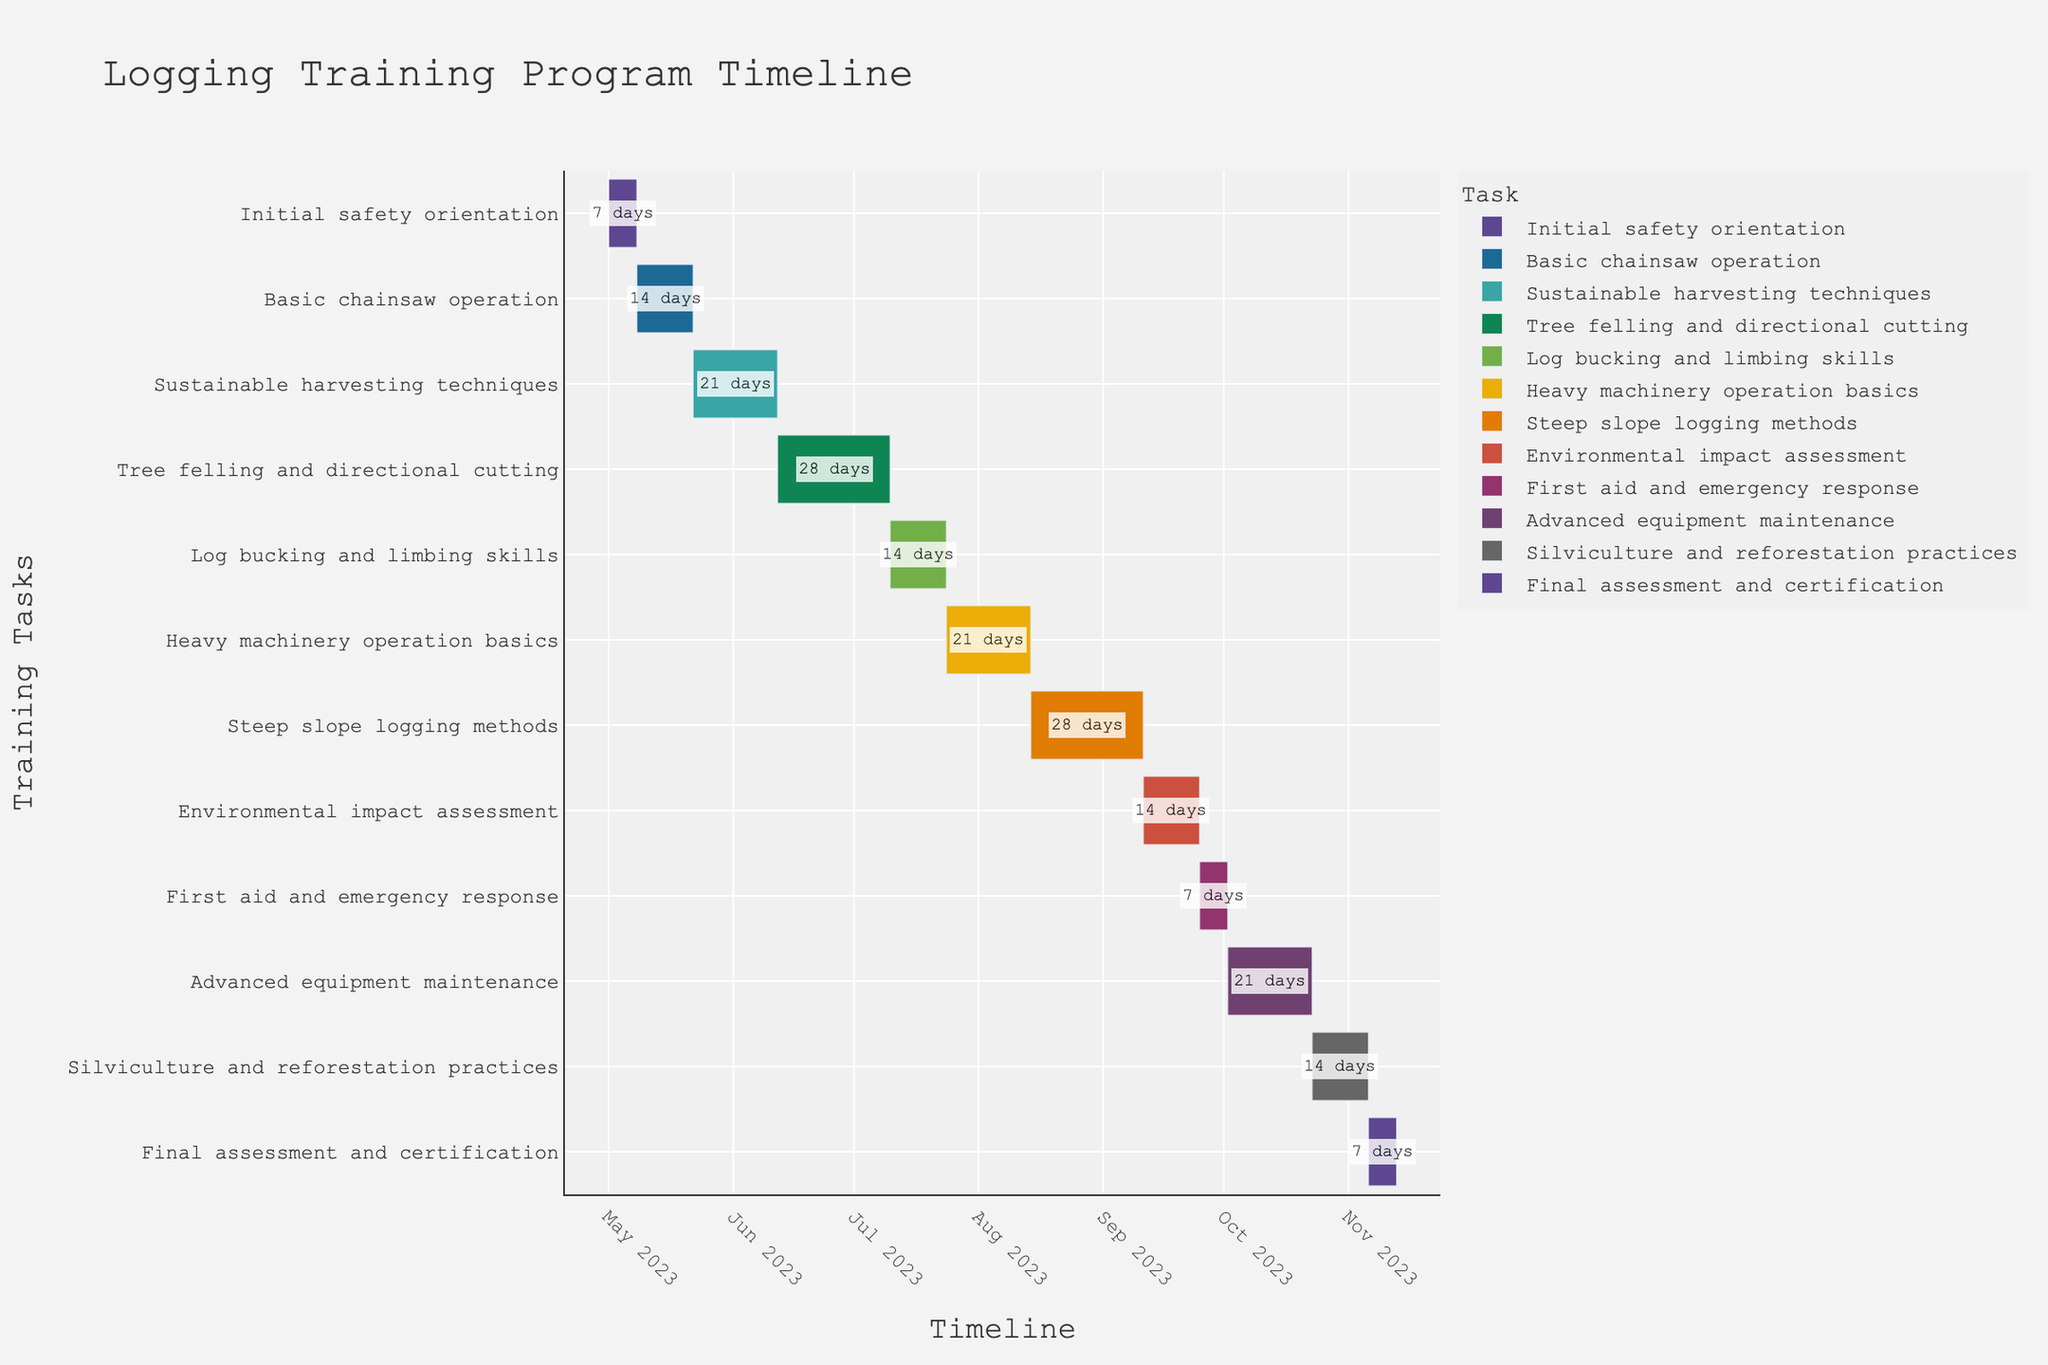Which task has the longest duration? Look for the task with the longest bar and check its duration annotation. "Tree felling and directional cutting" has a duration of 28 days, which is the longest.
Answer: Tree felling and directional cutting How many days is the total duration of all training tasks combined? Sum the duration of each task. The durations are 7+14+21+28+14+21+28+14+7+21+14+7 = 196 days.
Answer: 196 days Which task starts immediately after "Basic chainsaw operation"? Look for the tasks in date order. "Basic chainsaw operation" ends on 2023-05-21, and "Sustainable harvesting techniques" starts on 2023-05-22.
Answer: Sustainable harvesting techniques What is the duration of the "Final assessment and certification"? Check the annotation next to the "Final assessment and certification" task bar, which indicates a duration of 7 days.
Answer: 7 days Which two tasks have the same duration? Find tasks with equal duration annotations. Both "Basic chainsaw operation" and "Log bucking and limbing skills" have a duration of 14 days.
Answer: Basic chainsaw operation and Log bucking and limbing skills When does the "Environmental impact assessment" task end? The "Environmental impact assessment" starts on 2023-09-11 with a duration of 14 days, thus it ends on 2023-09-25.
Answer: 2023-09-25 What is the average duration of all tasks? Calculate the average duration by summing up all durations and dividing by the number of tasks. Sum is 196 days and number of tasks is 12, so the average is 196/12 = 16.33 days.
Answer: 16.33 days Which task has the shortest duration? Look for the task with the shortest bar and check its duration annotation. Both "Initial safety orientation" and "First aid and emergency response" have durations of 7 days, which are the shortest.
Answer: Initial safety orientation and First aid and emergency response Are there any tasks that overlap in their timelines? Check the start and end dates of each task. Tasks such as "Tree felling and directional cutting" and "Log bucking and limbing skills" overlap in their timelines.
Answer: Yes 